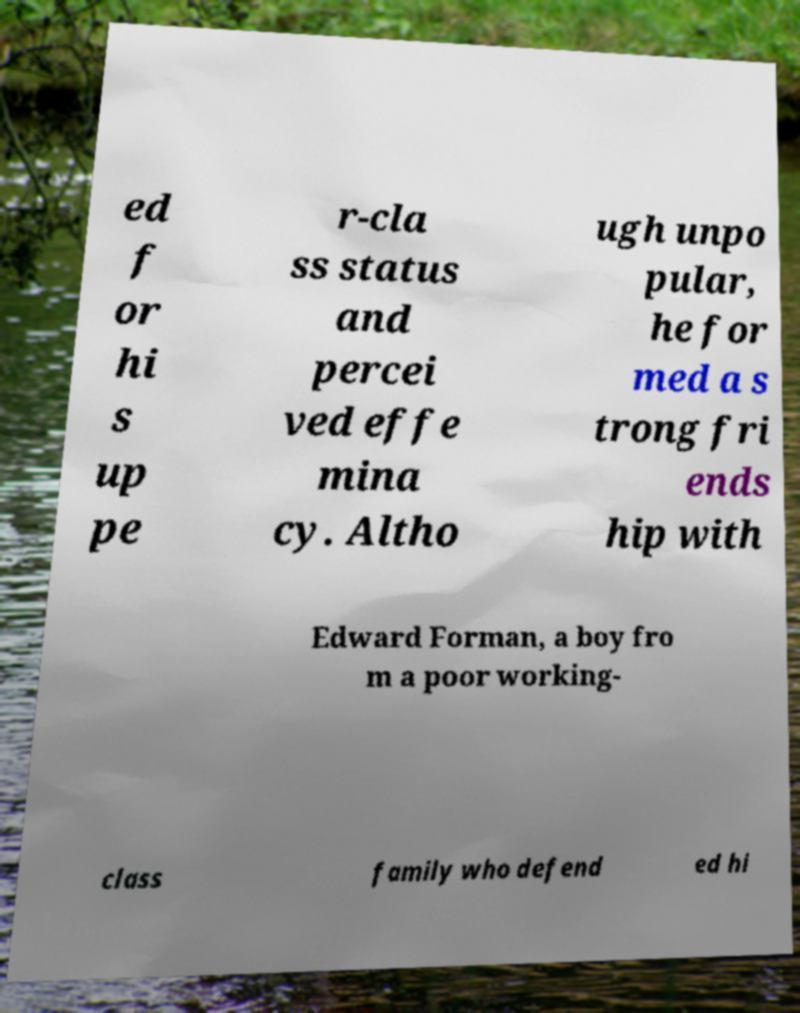Please identify and transcribe the text found in this image. ed f or hi s up pe r-cla ss status and percei ved effe mina cy. Altho ugh unpo pular, he for med a s trong fri ends hip with Edward Forman, a boy fro m a poor working- class family who defend ed hi 